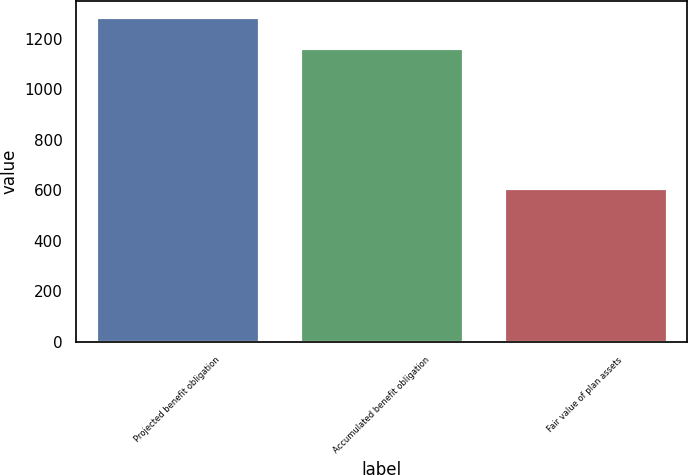Convert chart. <chart><loc_0><loc_0><loc_500><loc_500><bar_chart><fcel>Projected benefit obligation<fcel>Accumulated benefit obligation<fcel>Fair value of plan assets<nl><fcel>1284<fcel>1163<fcel>610<nl></chart> 